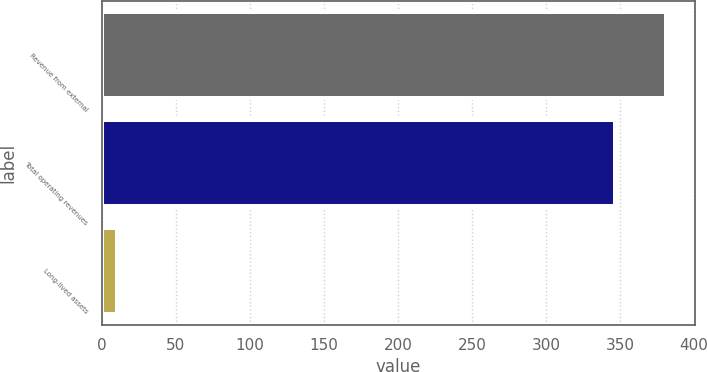Convert chart to OTSL. <chart><loc_0><loc_0><loc_500><loc_500><bar_chart><fcel>Revenue from external<fcel>Total operating revenues<fcel>Long-lived assets<nl><fcel>381.29<fcel>346.9<fcel>10<nl></chart> 